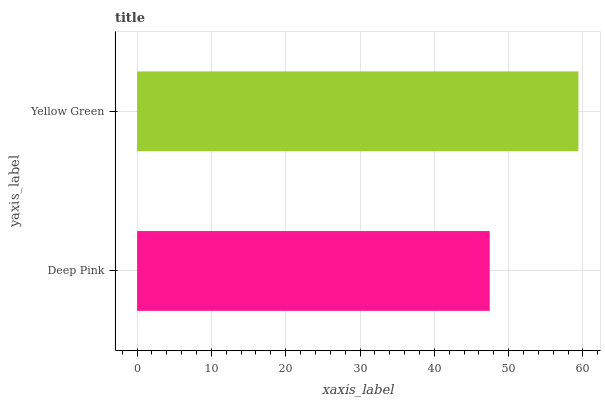Is Deep Pink the minimum?
Answer yes or no. Yes. Is Yellow Green the maximum?
Answer yes or no. Yes. Is Yellow Green the minimum?
Answer yes or no. No. Is Yellow Green greater than Deep Pink?
Answer yes or no. Yes. Is Deep Pink less than Yellow Green?
Answer yes or no. Yes. Is Deep Pink greater than Yellow Green?
Answer yes or no. No. Is Yellow Green less than Deep Pink?
Answer yes or no. No. Is Yellow Green the high median?
Answer yes or no. Yes. Is Deep Pink the low median?
Answer yes or no. Yes. Is Deep Pink the high median?
Answer yes or no. No. Is Yellow Green the low median?
Answer yes or no. No. 